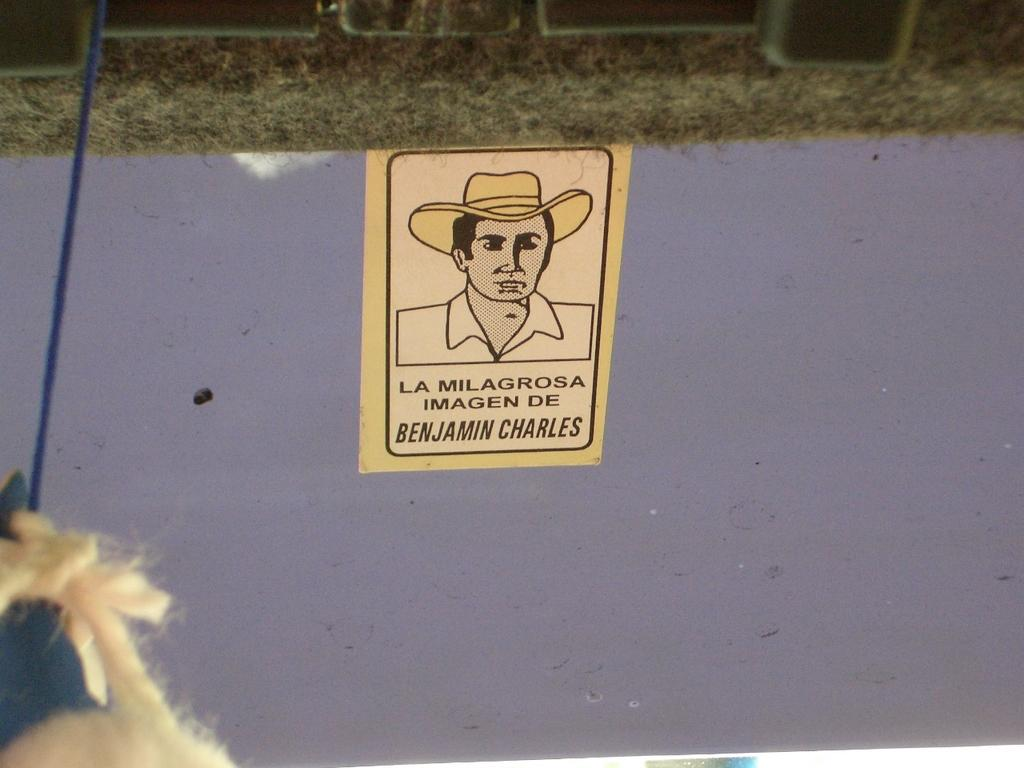Who is depicted on the poster in the image? There is a poster of a man in the image. What object can be seen in the image besides the poster? There is a rope in the image. What type of natural environment is visible in the background of the image? There is grass visible in the background of the image. What type of berry can be seen growing on the rope in the image? There are no berries present in the image, and the rope is not associated with any plant growth. 